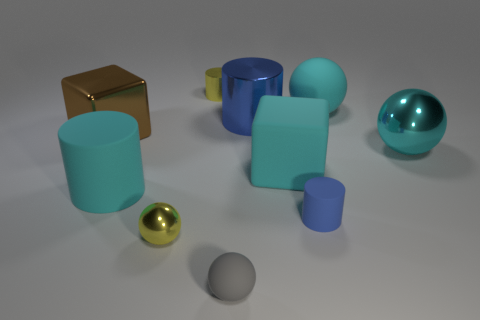Is there any particular object that stands out, and why? The golden sphere stands out due to its distinct color that contrasts with the predominantly cool color palette of the scene. Its shiny surface also reflects the environment, drawing the viewer's eye and making it a focal point against the more subdued matte textures. 